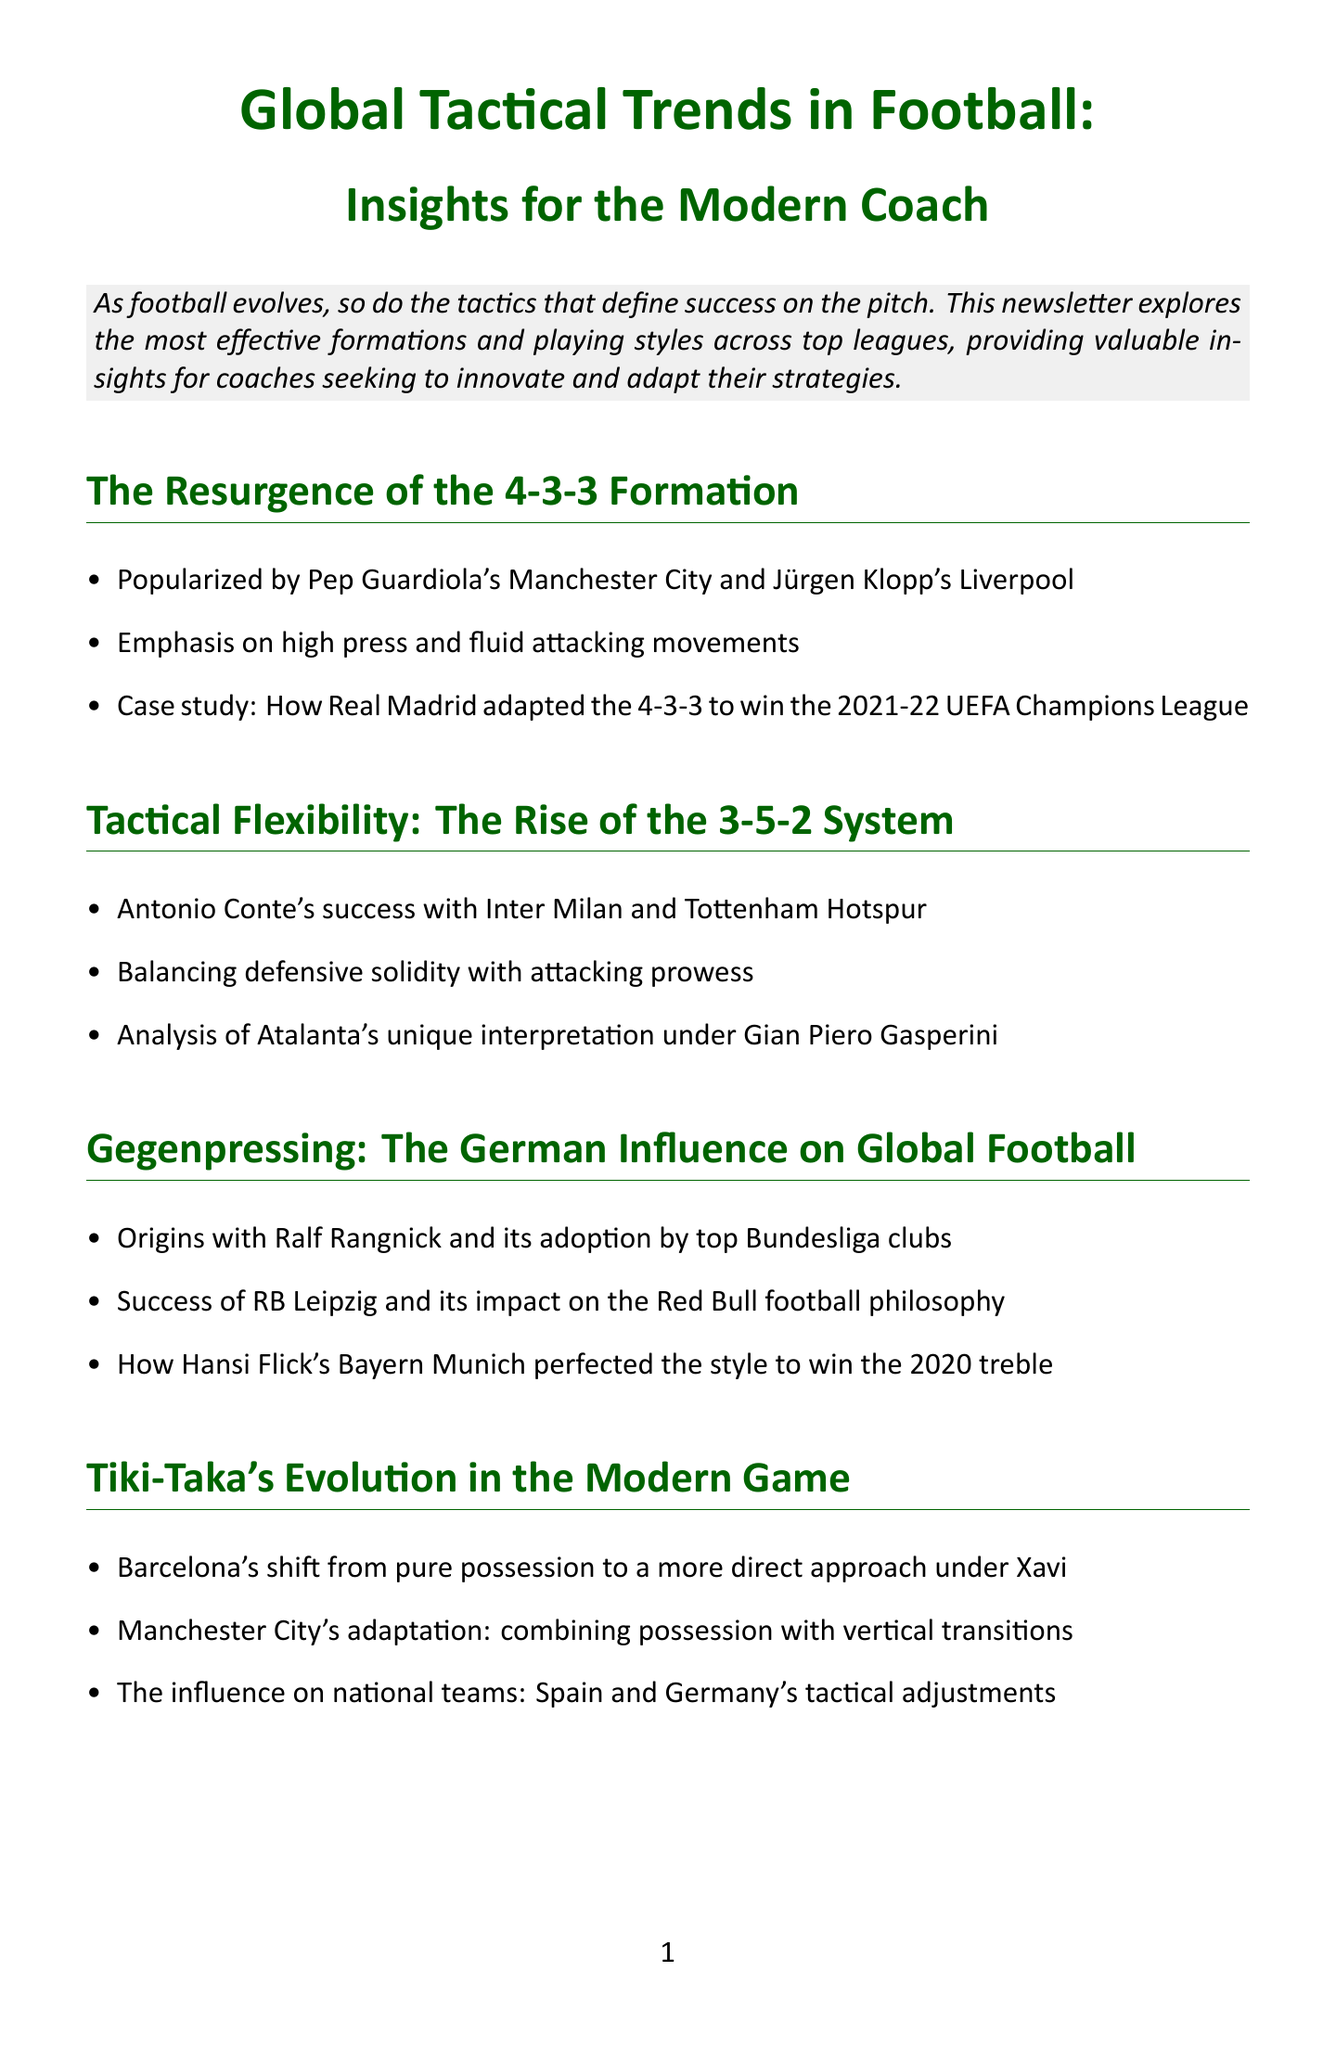What is the title of the newsletter? The title provides an overview of the main topic discussed in the document.
Answer: Global Tactical Trends in Football: Insights for the Modern Coach Who popularized the 4-3-3 formation? This is mentioned as a significant contribution to the football tactics in the document.
Answer: Pep Guardiola and Jürgen Klopp Which formation is discussed in relation to Antonio Conte? The document highlights different tactical formations along with their successful applications by various coaches.
Answer: 3-5-2 System What is a key characteristic of gegenpressing? The content discusses the origins of this tactical approach and its influence on football.
Answer: High press How many coaching tips are provided in the newsletter? The document includes a section dedicated to coaching tips for practical application.
Answer: Four Which club's adaptation of tiki-taka is mentioned? This club is cited as evolving its playing style in the context of modern game strategies.
Answer: Barcelona What was a major success of Hansi Flick's Bayern Munich? The document summarizes achievements of various teams, including key victories under specific tactical styles.
Answer: 2020 treble What is a common theme among successful teams according to the conclusion? The conclusion synthesizes the insights from various sections and emphasizes a particular strategic approach.
Answer: Blending multiple tactical approaches What coaching philosophy does the author advocate for? This is summarized in the section about the author's background and beliefs regarding coaching.
Answer: Bridging the gap between tactical theory and practical application 